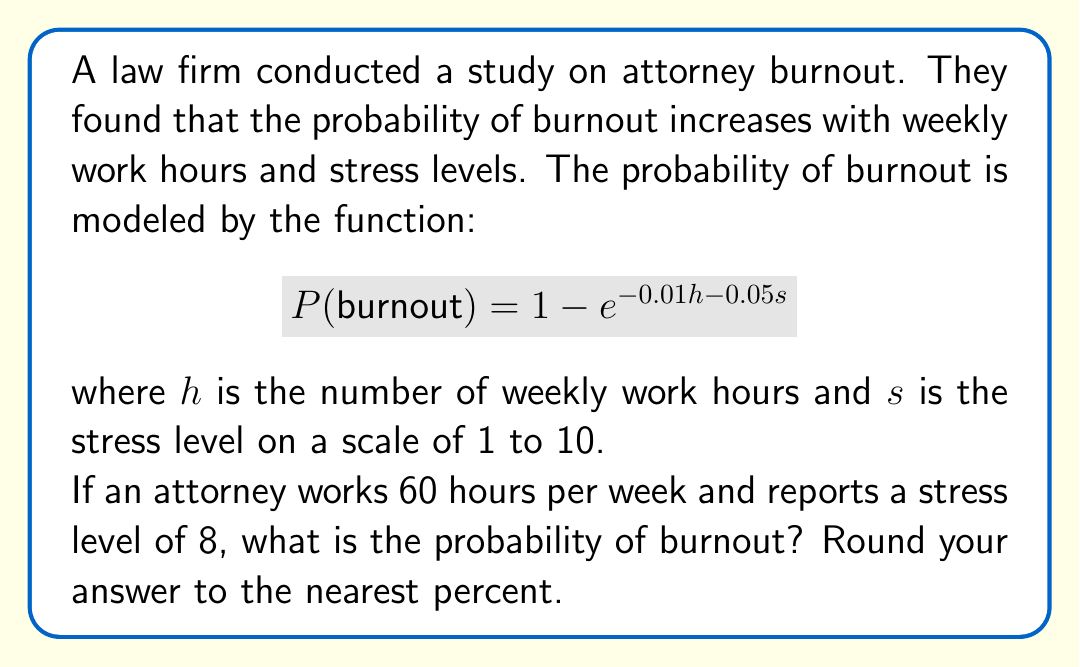Give your solution to this math problem. Let's approach this step-by-step:

1) We are given the probability function:
   $$P(burnout) = 1 - e^{-0.01h - 0.05s}$$

2) We know the values for $h$ and $s$:
   $h = 60$ (weekly work hours)
   $s = 8$ (stress level)

3) Let's substitute these values into the equation:
   $$P(burnout) = 1 - e^{-0.01(60) - 0.05(8)}$$

4) Simplify the exponent:
   $$P(burnout) = 1 - e^{-0.6 - 0.4}$$
   $$P(burnout) = 1 - e^{-1}$$

5) Calculate $e^{-1}$:
   $$P(burnout) = 1 - 0.3679$$

6) Subtract:
   $$P(burnout) = 0.6321$$

7) Convert to a percentage and round to the nearest percent:
   $$P(burnout) = 63.21\% \approx 63\%$$
Answer: 63% 